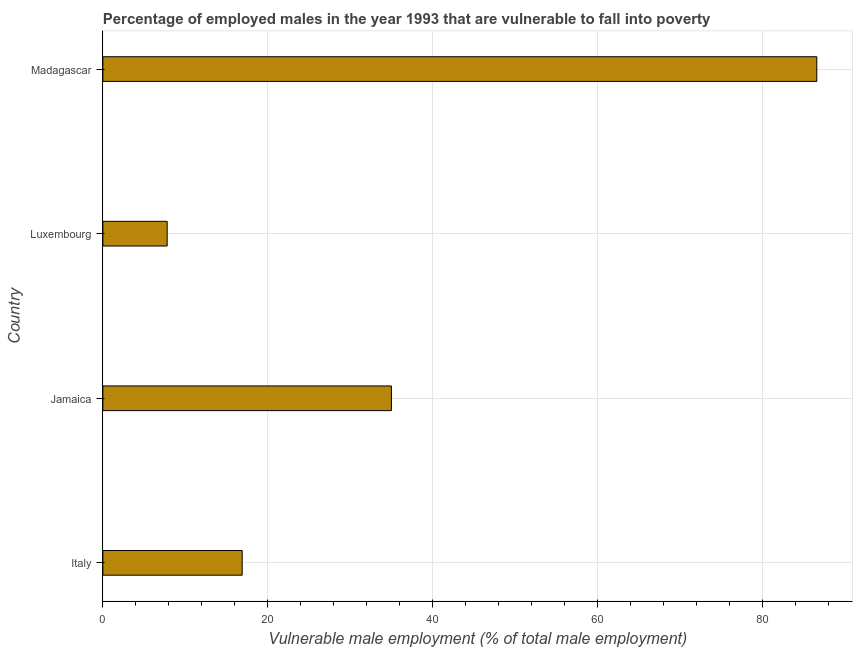Does the graph contain grids?
Offer a very short reply. Yes. What is the title of the graph?
Provide a succinct answer. Percentage of employed males in the year 1993 that are vulnerable to fall into poverty. What is the label or title of the X-axis?
Offer a very short reply. Vulnerable male employment (% of total male employment). What is the label or title of the Y-axis?
Your response must be concise. Country. What is the percentage of employed males who are vulnerable to fall into poverty in Madagascar?
Offer a very short reply. 86.6. Across all countries, what is the maximum percentage of employed males who are vulnerable to fall into poverty?
Provide a succinct answer. 86.6. Across all countries, what is the minimum percentage of employed males who are vulnerable to fall into poverty?
Provide a succinct answer. 7.8. In which country was the percentage of employed males who are vulnerable to fall into poverty maximum?
Provide a succinct answer. Madagascar. In which country was the percentage of employed males who are vulnerable to fall into poverty minimum?
Offer a terse response. Luxembourg. What is the sum of the percentage of employed males who are vulnerable to fall into poverty?
Provide a succinct answer. 146.3. What is the difference between the percentage of employed males who are vulnerable to fall into poverty in Jamaica and Luxembourg?
Make the answer very short. 27.2. What is the average percentage of employed males who are vulnerable to fall into poverty per country?
Offer a very short reply. 36.58. What is the median percentage of employed males who are vulnerable to fall into poverty?
Give a very brief answer. 25.95. In how many countries, is the percentage of employed males who are vulnerable to fall into poverty greater than 84 %?
Provide a succinct answer. 1. What is the ratio of the percentage of employed males who are vulnerable to fall into poverty in Italy to that in Jamaica?
Your response must be concise. 0.48. Is the percentage of employed males who are vulnerable to fall into poverty in Italy less than that in Jamaica?
Provide a short and direct response. Yes. Is the difference between the percentage of employed males who are vulnerable to fall into poverty in Italy and Jamaica greater than the difference between any two countries?
Offer a terse response. No. What is the difference between the highest and the second highest percentage of employed males who are vulnerable to fall into poverty?
Keep it short and to the point. 51.6. What is the difference between the highest and the lowest percentage of employed males who are vulnerable to fall into poverty?
Your answer should be compact. 78.8. Are all the bars in the graph horizontal?
Offer a very short reply. Yes. How many countries are there in the graph?
Give a very brief answer. 4. What is the difference between two consecutive major ticks on the X-axis?
Provide a short and direct response. 20. What is the Vulnerable male employment (% of total male employment) of Italy?
Offer a terse response. 16.9. What is the Vulnerable male employment (% of total male employment) in Jamaica?
Offer a terse response. 35. What is the Vulnerable male employment (% of total male employment) of Luxembourg?
Your answer should be very brief. 7.8. What is the Vulnerable male employment (% of total male employment) in Madagascar?
Provide a succinct answer. 86.6. What is the difference between the Vulnerable male employment (% of total male employment) in Italy and Jamaica?
Keep it short and to the point. -18.1. What is the difference between the Vulnerable male employment (% of total male employment) in Italy and Madagascar?
Keep it short and to the point. -69.7. What is the difference between the Vulnerable male employment (% of total male employment) in Jamaica and Luxembourg?
Provide a short and direct response. 27.2. What is the difference between the Vulnerable male employment (% of total male employment) in Jamaica and Madagascar?
Offer a terse response. -51.6. What is the difference between the Vulnerable male employment (% of total male employment) in Luxembourg and Madagascar?
Provide a short and direct response. -78.8. What is the ratio of the Vulnerable male employment (% of total male employment) in Italy to that in Jamaica?
Your answer should be very brief. 0.48. What is the ratio of the Vulnerable male employment (% of total male employment) in Italy to that in Luxembourg?
Provide a short and direct response. 2.17. What is the ratio of the Vulnerable male employment (% of total male employment) in Italy to that in Madagascar?
Offer a very short reply. 0.2. What is the ratio of the Vulnerable male employment (% of total male employment) in Jamaica to that in Luxembourg?
Offer a very short reply. 4.49. What is the ratio of the Vulnerable male employment (% of total male employment) in Jamaica to that in Madagascar?
Give a very brief answer. 0.4. What is the ratio of the Vulnerable male employment (% of total male employment) in Luxembourg to that in Madagascar?
Offer a terse response. 0.09. 